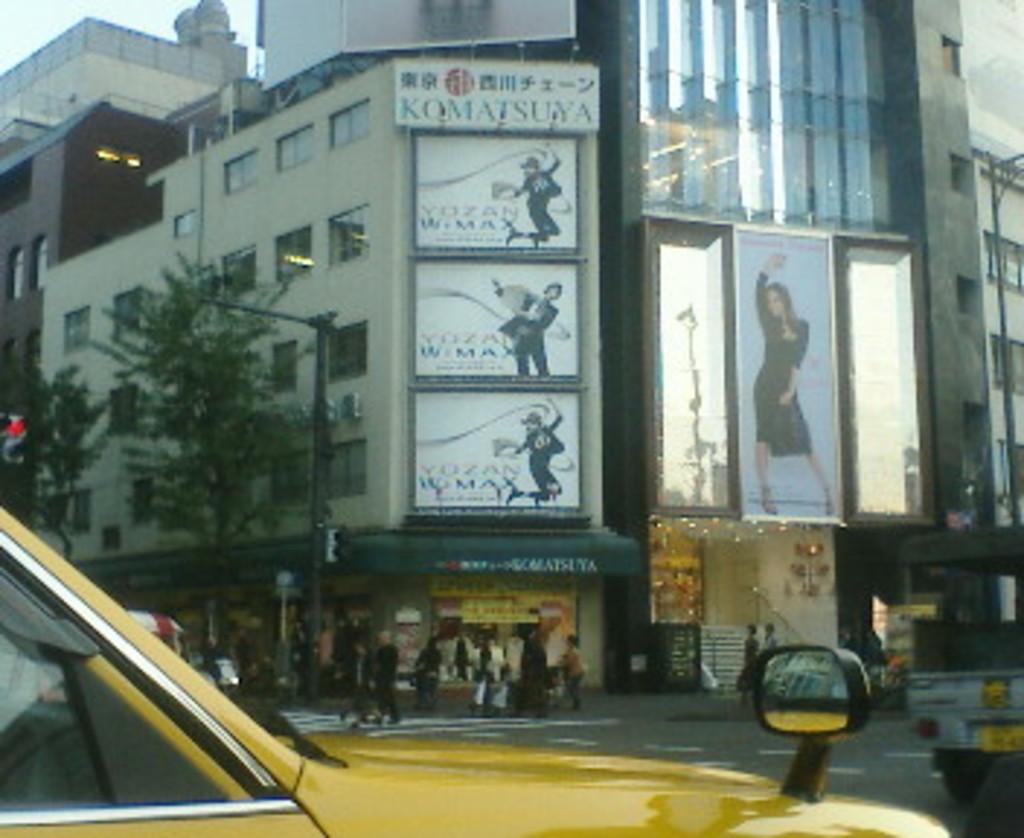What is the first word of the three similar pictures in the middle?
Offer a terse response. Yozan. 